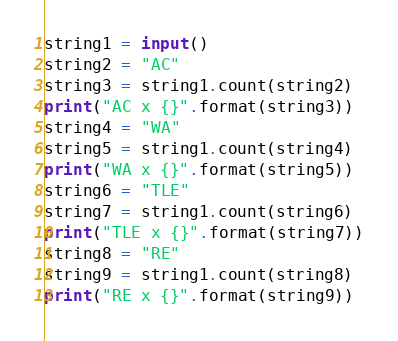<code> <loc_0><loc_0><loc_500><loc_500><_Python_>string1 = input()
string2 = "AC" 
string3 = string1.count(string2)
print("AC x {}".format(string3))
string4 = "WA" 
string5 = string1.count(string4)
print("WA x {}".format(string5))
string6 = "TLE" 
string7 = string1.count(string6)
print("TLE x {}".format(string7))
string8 = "RE" 
string9 = string1.count(string8)
print("RE x {}".format(string9))</code> 